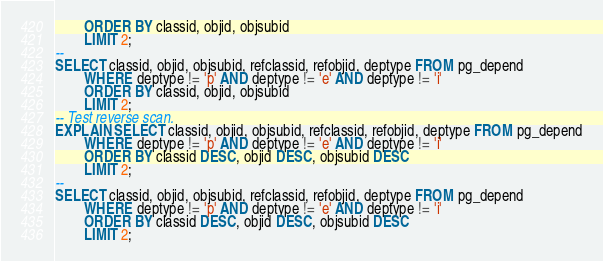Convert code to text. <code><loc_0><loc_0><loc_500><loc_500><_SQL_>		ORDER BY classid, objid, objsubid
		LIMIT 2;
--
SELECT classid, objid, objsubid, refclassid, refobjid, deptype FROM pg_depend
		WHERE deptype != 'p' AND deptype != 'e' AND deptype != 'i'
		ORDER BY classid, objid, objsubid
		LIMIT 2;
-- Test reverse scan.
EXPLAIN SELECT classid, objid, objsubid, refclassid, refobjid, deptype FROM pg_depend
		WHERE deptype != 'p' AND deptype != 'e' AND deptype != 'i'
		ORDER BY classid DESC, objid DESC, objsubid DESC
		LIMIT 2;
--
SELECT classid, objid, objsubid, refclassid, refobjid, deptype FROM pg_depend
		WHERE deptype != 'p' AND deptype != 'e' AND deptype != 'i'
		ORDER BY classid DESC, objid DESC, objsubid DESC
		LIMIT 2;
</code> 